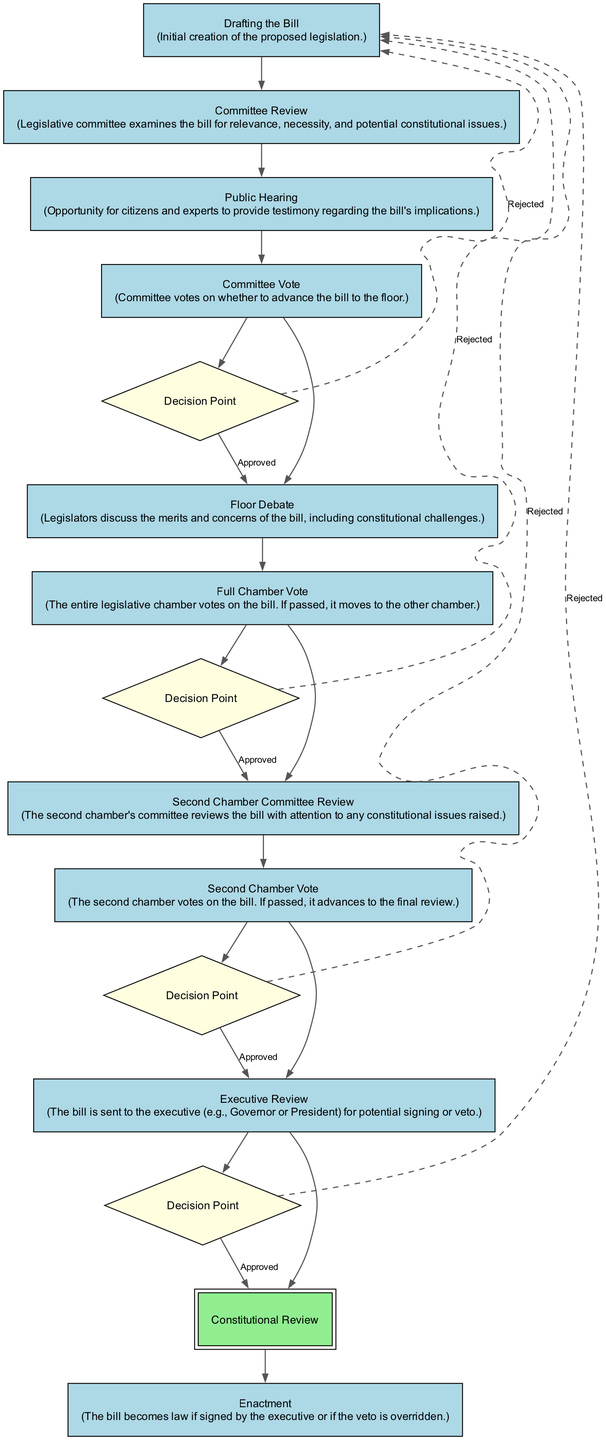What is the first step in the legislative process? The diagram outlines 'Drafting the Bill' as the first step, indicating that the initial creation of the proposed legislation is where the process begins.
Answer: Drafting the Bill What happens after Committee Review? The flow chart indicates that after the 'Committee Review' step, the process moves to 'Public Hearing', where citizens and experts can provide testimony regarding the bill's implications.
Answer: Public Hearing How many decision points are there in the flow chart? By examining the diagram, we can identify four decision points: Committee Vote, Full Chamber Vote, Second Chamber Vote, and Executive Review, indicating critical moments where the fate of the bill can be determined.
Answer: Four Which step involves a review for constitutional issues? The diagram shows that 'Constitutional Review' specifically focuses on ensuring the bill complies with constitutional standards before it can be enacted.
Answer: Constitutional Review What occurs if the 'Committee Vote' is rejected? According to the flow chart, if the 'Committee Vote' is rejected, the process indicates a dashed line leading back to the node referring to 'Drafting the Bill', suggesting the bill may need to be redrafted or reconsidered.
Answer: Drafting the Bill What is the last step in the legislative process? The concluding step in the diagram, 'Enactment', shows that the bill becomes law if signed by the executive or if the veto is overridden, representing the final stage of the process.
Answer: Enactment What role does the 'Executive Review' step play in the process? 'Executive Review' serves as the point where the bill is sent to the executive (Governor or President) for potential signing or veto, marking a significant decision point before it can become law.
Answer: Signing or Veto Which step emphasizes public involvement? The 'Public Hearing' step is highlighted as the moment when citizens and experts are afforded the opportunity to provide their input regarding the bill's implications, showcasing a key aspect of public participation in the legislative process.
Answer: Public Hearing How does the process return if a bill is rejected during the 'Second Chamber Vote'? The flow chart indicates that a rejection at the 'Second Chamber Vote' would lead back to 'Drafting the Bill', suggesting that the legislative process may loop back for further amendments or reconsiderations.
Answer: Drafting the Bill 